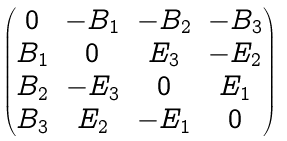Convert formula to latex. <formula><loc_0><loc_0><loc_500><loc_500>\begin{pmatrix} 0 & - B _ { 1 } & - B _ { 2 } & - B _ { 3 } \\ B _ { 1 } & 0 & E _ { 3 } & - E _ { 2 } \\ B _ { 2 } & - E _ { 3 } & 0 & E _ { 1 } \\ B _ { 3 } & E _ { 2 } & - E _ { 1 } & 0 \end{pmatrix}</formula> 